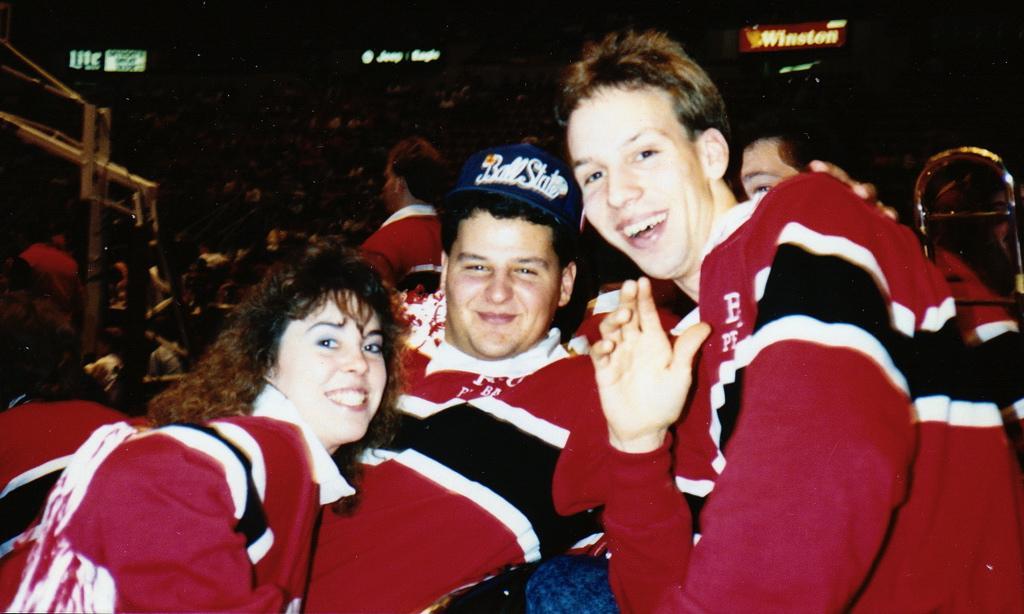Describe this image in one or two sentences. There are three persons. Person in the center is wearing a cap. In the back there are many people. Also there are many name boards with light. 